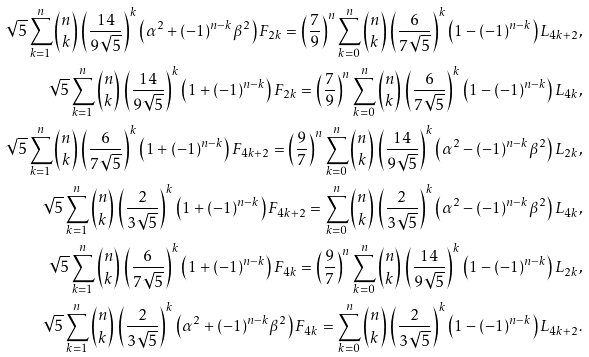<formula> <loc_0><loc_0><loc_500><loc_500>\sqrt { 5 } \sum _ { k = 1 } ^ { n } { n \choose k } \, \left ( \frac { 1 4 } { 9 \sqrt { 5 } } \right ) ^ { k } \left ( \alpha ^ { 2 } + ( - 1 ) ^ { n - k } \beta ^ { 2 } \right ) F _ { 2 k } = \left ( \frac { 7 } { 9 } \right ) ^ { n } \sum _ { k = 0 } ^ { n } { n \choose k } \, \left ( \frac { 6 } { 7 \sqrt { 5 } } \right ) ^ { k } \left ( 1 - ( - 1 ) ^ { n - k } \right ) L _ { 4 k + 2 } , \\ \sqrt { 5 } \sum _ { k = 1 } ^ { n } { n \choose k } \, \left ( \frac { 1 4 } { 9 \sqrt { 5 } } \right ) ^ { k } \left ( 1 + ( - 1 ) ^ { n - k } \right ) F _ { 2 k } = \left ( \frac { 7 } { 9 } \right ) ^ { n } \sum _ { k = 0 } ^ { n } { n \choose k } \, \left ( \frac { 6 } { 7 \sqrt { 5 } } \right ) ^ { k } \left ( 1 - ( - 1 ) ^ { n - k } \right ) L _ { 4 k } , \\ \sqrt { 5 } \sum _ { k = 1 } ^ { n } { n \choose k } \, \left ( \frac { 6 } { 7 \sqrt { 5 } } \right ) ^ { k } \left ( 1 + ( - 1 ) ^ { n - k } \right ) F _ { 4 k + 2 } = \left ( \frac { 9 } { 7 } \right ) ^ { n } \sum _ { k = 0 } ^ { n } { n \choose k } \, \left ( \frac { 1 4 } { 9 \sqrt { 5 } } \right ) ^ { k } \left ( \alpha ^ { 2 } - ( - 1 ) ^ { n - k } \beta ^ { 2 } \right ) L _ { 2 k } , \\ \sqrt { 5 } \sum _ { k = 1 } ^ { n } { n \choose k } \, \left ( \frac { 2 } { 3 \sqrt { 5 } } \right ) ^ { k } \left ( 1 + ( - 1 ) ^ { n - k } \right ) F _ { 4 k + 2 } = \sum _ { k = 0 } ^ { n } { n \choose k } \, \left ( \frac { 2 } { 3 \sqrt { 5 } } \right ) ^ { k } \left ( \alpha ^ { 2 } - ( - 1 ) ^ { n - k } \beta ^ { 2 } \right ) L _ { 4 k } , \\ \sqrt { 5 } \sum _ { k = 1 } ^ { n } { n \choose k } \, \left ( \frac { 6 } { 7 \sqrt { 5 } } \right ) ^ { k } \left ( 1 + ( - 1 ) ^ { n - k } \right ) F _ { 4 k } = \left ( \frac { 9 } { 7 } \right ) ^ { n } \sum _ { k = 0 } ^ { n } { n \choose k } \, \left ( \frac { 1 4 } { 9 \sqrt { 5 } } \right ) ^ { k } \left ( 1 - ( - 1 ) ^ { n - k } \right ) L _ { 2 k } , \\ \sqrt { 5 } \sum _ { k = 1 } ^ { n } { n \choose k } \, \left ( \frac { 2 } { 3 \sqrt { 5 } } \right ) ^ { k } \left ( \alpha ^ { 2 } + ( - 1 ) ^ { n - k } \beta ^ { 2 } \right ) F _ { 4 k } = \sum _ { k = 0 } ^ { n } { n \choose k } \, \left ( \frac { 2 } { 3 \sqrt { 5 } } \right ) ^ { k } \left ( 1 - ( - 1 ) ^ { n - k } \right ) L _ { 4 k + 2 } .</formula> 